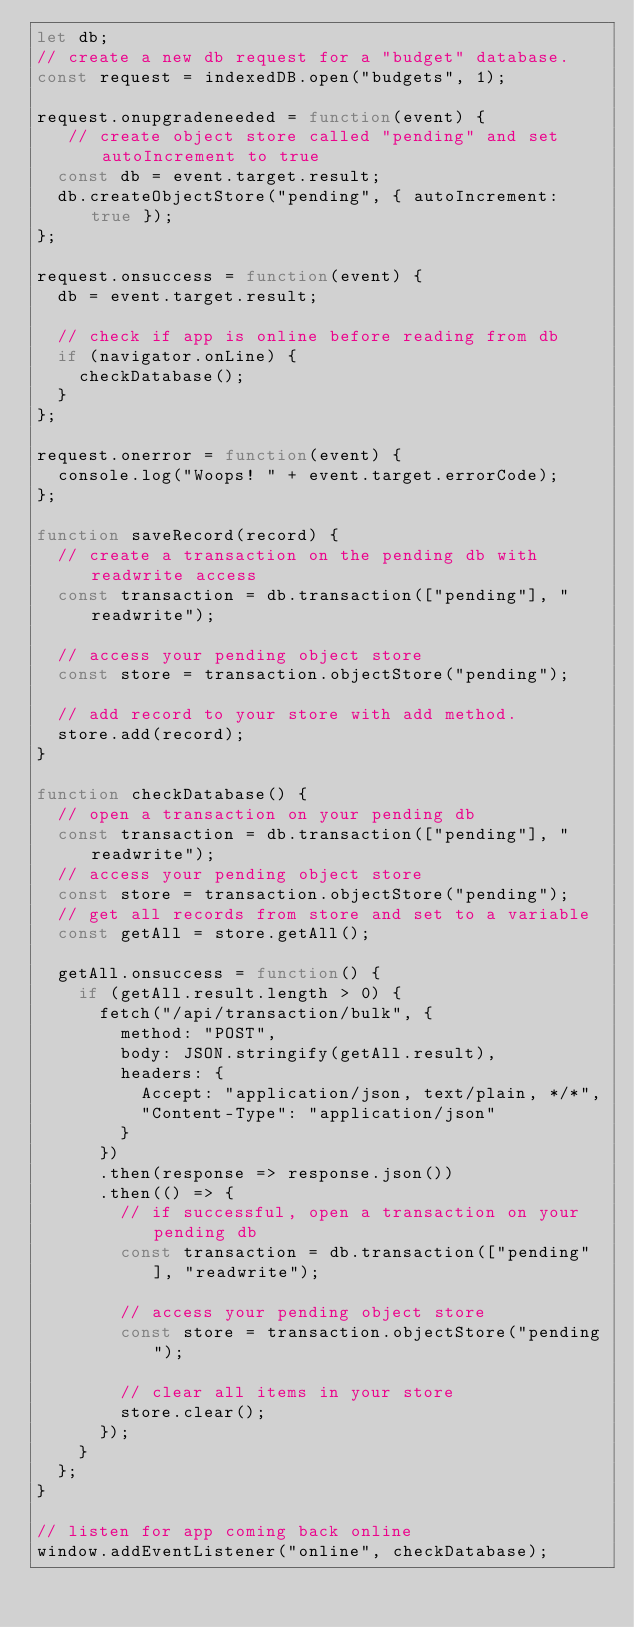<code> <loc_0><loc_0><loc_500><loc_500><_JavaScript_>let db;
// create a new db request for a "budget" database.
const request = indexedDB.open("budgets", 1);

request.onupgradeneeded = function(event) {
   // create object store called "pending" and set autoIncrement to true
  const db = event.target.result;
  db.createObjectStore("pending", { autoIncrement: true });
};

request.onsuccess = function(event) {
  db = event.target.result;

  // check if app is online before reading from db
  if (navigator.onLine) {
    checkDatabase();
  }
};

request.onerror = function(event) {
  console.log("Woops! " + event.target.errorCode);
};

function saveRecord(record) {
  // create a transaction on the pending db with readwrite access
  const transaction = db.transaction(["pending"], "readwrite");

  // access your pending object store
  const store = transaction.objectStore("pending");

  // add record to your store with add method.
  store.add(record);
}

function checkDatabase() {
  // open a transaction on your pending db
  const transaction = db.transaction(["pending"], "readwrite");
  // access your pending object store
  const store = transaction.objectStore("pending");
  // get all records from store and set to a variable
  const getAll = store.getAll();

  getAll.onsuccess = function() {
    if (getAll.result.length > 0) {
      fetch("/api/transaction/bulk", {
        method: "POST",
        body: JSON.stringify(getAll.result),
        headers: {
          Accept: "application/json, text/plain, */*",
          "Content-Type": "application/json"
        }
      })
      .then(response => response.json())
      .then(() => {
        // if successful, open a transaction on your pending db
        const transaction = db.transaction(["pending"], "readwrite");

        // access your pending object store
        const store = transaction.objectStore("pending");

        // clear all items in your store
        store.clear();
      });
    }
  };
}

// listen for app coming back online
window.addEventListener("online", checkDatabase);</code> 